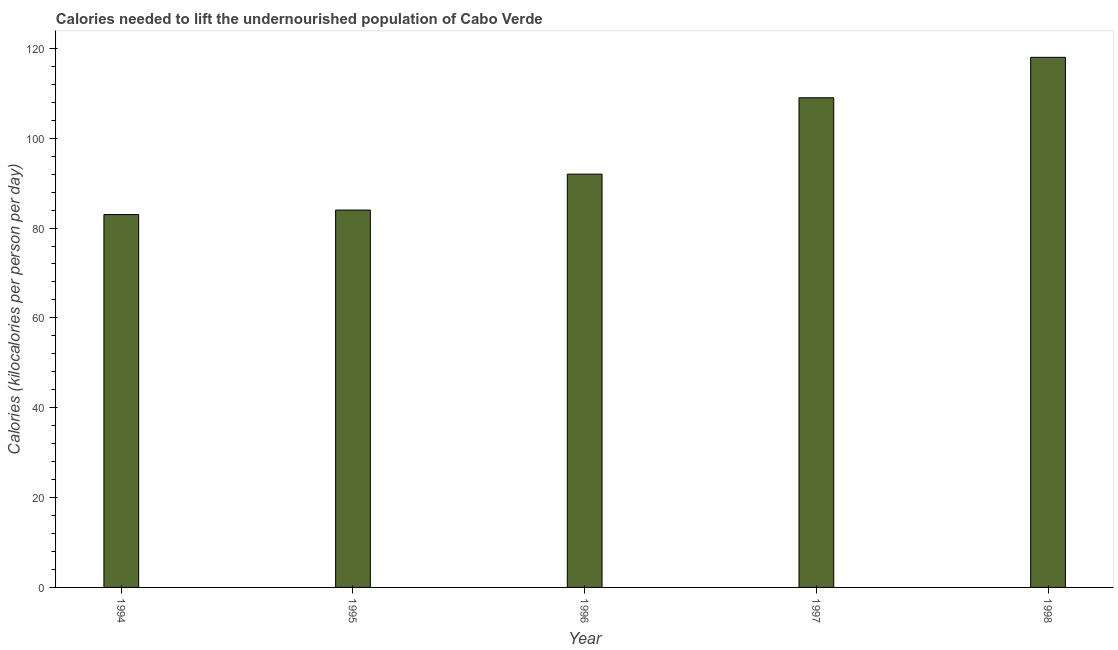Does the graph contain any zero values?
Your answer should be very brief. No. Does the graph contain grids?
Your response must be concise. No. What is the title of the graph?
Offer a terse response. Calories needed to lift the undernourished population of Cabo Verde. What is the label or title of the X-axis?
Offer a terse response. Year. What is the label or title of the Y-axis?
Your answer should be very brief. Calories (kilocalories per person per day). What is the depth of food deficit in 1994?
Your response must be concise. 83. Across all years, what is the maximum depth of food deficit?
Offer a terse response. 118. Across all years, what is the minimum depth of food deficit?
Give a very brief answer. 83. In which year was the depth of food deficit minimum?
Make the answer very short. 1994. What is the sum of the depth of food deficit?
Provide a succinct answer. 486. What is the difference between the depth of food deficit in 1996 and 1998?
Your answer should be compact. -26. What is the average depth of food deficit per year?
Offer a terse response. 97. What is the median depth of food deficit?
Keep it short and to the point. 92. In how many years, is the depth of food deficit greater than 64 kilocalories?
Your response must be concise. 5. Do a majority of the years between 1997 and 1996 (inclusive) have depth of food deficit greater than 8 kilocalories?
Offer a terse response. No. What is the ratio of the depth of food deficit in 1994 to that in 1996?
Offer a very short reply. 0.9. Is the difference between the depth of food deficit in 1995 and 1997 greater than the difference between any two years?
Offer a very short reply. No. Is the sum of the depth of food deficit in 1997 and 1998 greater than the maximum depth of food deficit across all years?
Offer a terse response. Yes. What is the difference between two consecutive major ticks on the Y-axis?
Provide a short and direct response. 20. What is the Calories (kilocalories per person per day) in 1996?
Provide a short and direct response. 92. What is the Calories (kilocalories per person per day) of 1997?
Provide a short and direct response. 109. What is the Calories (kilocalories per person per day) in 1998?
Your response must be concise. 118. What is the difference between the Calories (kilocalories per person per day) in 1994 and 1995?
Ensure brevity in your answer.  -1. What is the difference between the Calories (kilocalories per person per day) in 1994 and 1998?
Offer a very short reply. -35. What is the difference between the Calories (kilocalories per person per day) in 1995 and 1996?
Your answer should be very brief. -8. What is the difference between the Calories (kilocalories per person per day) in 1995 and 1997?
Provide a short and direct response. -25. What is the difference between the Calories (kilocalories per person per day) in 1995 and 1998?
Offer a terse response. -34. What is the difference between the Calories (kilocalories per person per day) in 1996 and 1998?
Offer a very short reply. -26. What is the ratio of the Calories (kilocalories per person per day) in 1994 to that in 1995?
Provide a succinct answer. 0.99. What is the ratio of the Calories (kilocalories per person per day) in 1994 to that in 1996?
Make the answer very short. 0.9. What is the ratio of the Calories (kilocalories per person per day) in 1994 to that in 1997?
Ensure brevity in your answer.  0.76. What is the ratio of the Calories (kilocalories per person per day) in 1994 to that in 1998?
Make the answer very short. 0.7. What is the ratio of the Calories (kilocalories per person per day) in 1995 to that in 1997?
Your answer should be compact. 0.77. What is the ratio of the Calories (kilocalories per person per day) in 1995 to that in 1998?
Provide a succinct answer. 0.71. What is the ratio of the Calories (kilocalories per person per day) in 1996 to that in 1997?
Your answer should be compact. 0.84. What is the ratio of the Calories (kilocalories per person per day) in 1996 to that in 1998?
Provide a succinct answer. 0.78. What is the ratio of the Calories (kilocalories per person per day) in 1997 to that in 1998?
Give a very brief answer. 0.92. 